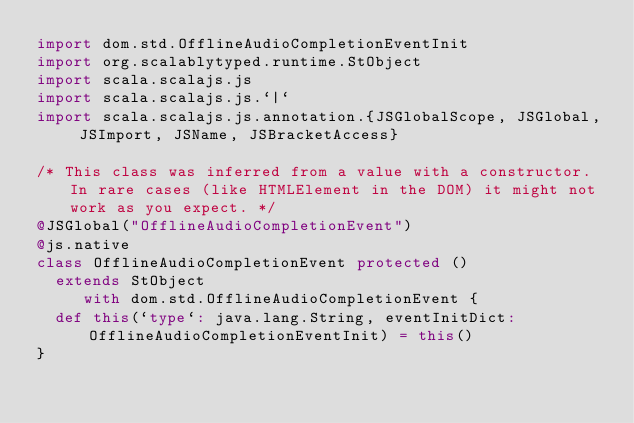Convert code to text. <code><loc_0><loc_0><loc_500><loc_500><_Scala_>import dom.std.OfflineAudioCompletionEventInit
import org.scalablytyped.runtime.StObject
import scala.scalajs.js
import scala.scalajs.js.`|`
import scala.scalajs.js.annotation.{JSGlobalScope, JSGlobal, JSImport, JSName, JSBracketAccess}

/* This class was inferred from a value with a constructor. In rare cases (like HTMLElement in the DOM) it might not work as you expect. */
@JSGlobal("OfflineAudioCompletionEvent")
@js.native
class OfflineAudioCompletionEvent protected ()
  extends StObject
     with dom.std.OfflineAudioCompletionEvent {
  def this(`type`: java.lang.String, eventInitDict: OfflineAudioCompletionEventInit) = this()
}
</code> 